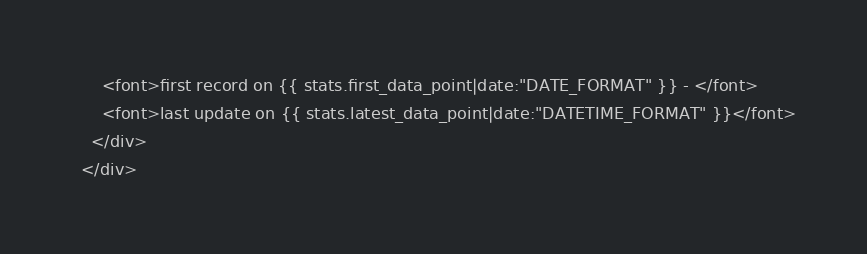Convert code to text. <code><loc_0><loc_0><loc_500><loc_500><_HTML_>      <font>first record on {{ stats.first_data_point|date:"DATE_FORMAT" }} - </font>
      <font>last update on {{ stats.latest_data_point|date:"DATETIME_FORMAT" }}</font>
    </div>
  </div></code> 